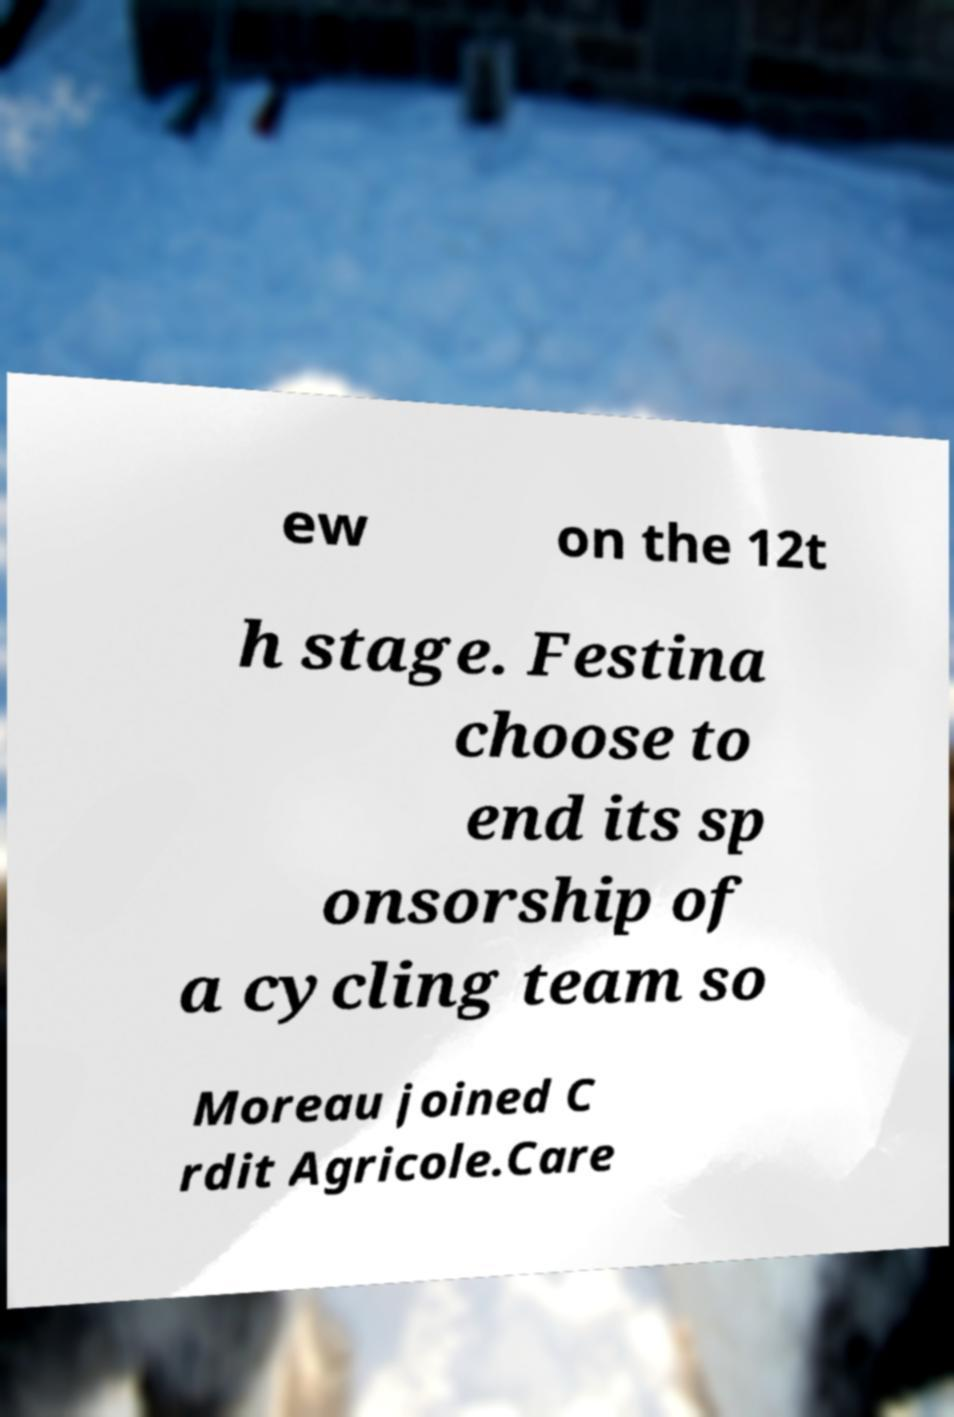There's text embedded in this image that I need extracted. Can you transcribe it verbatim? ew on the 12t h stage. Festina choose to end its sp onsorship of a cycling team so Moreau joined C rdit Agricole.Care 